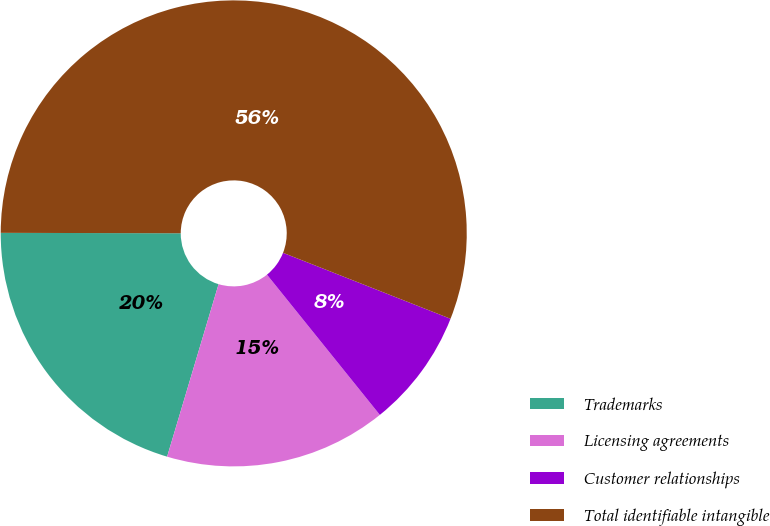Convert chart to OTSL. <chart><loc_0><loc_0><loc_500><loc_500><pie_chart><fcel>Trademarks<fcel>Licensing agreements<fcel>Customer relationships<fcel>Total identifiable intangible<nl><fcel>20.42%<fcel>15.4%<fcel>8.24%<fcel>55.93%<nl></chart> 